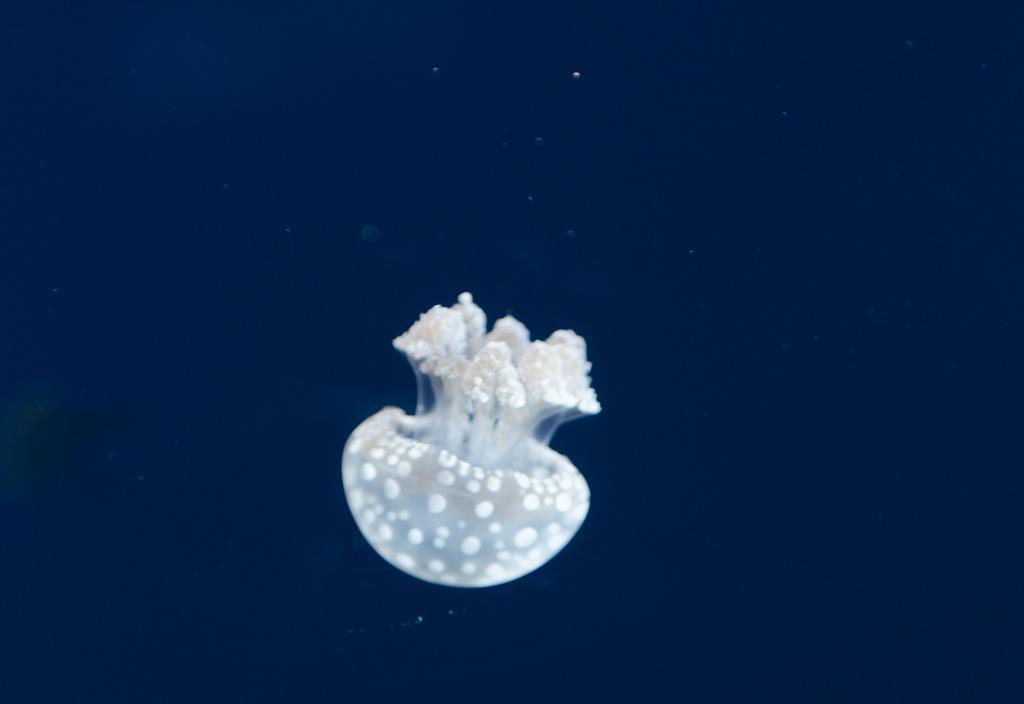Please provide a concise description of this image. In this image I can see an aquatic animal and background is in navy-blue color. 